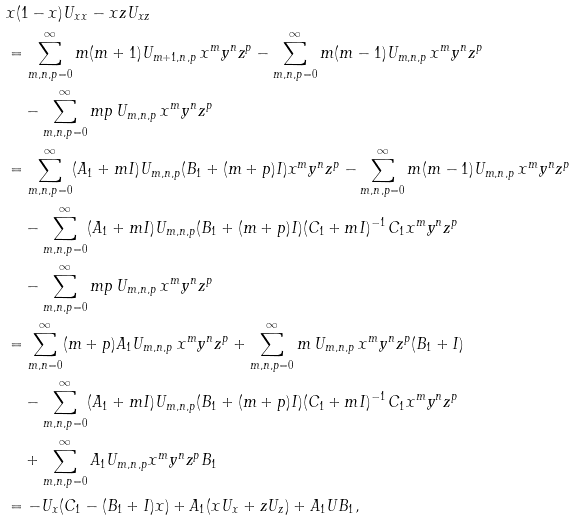<formula> <loc_0><loc_0><loc_500><loc_500>& x ( 1 - x ) U _ { x x } - x z U _ { x z } \\ & = \sum _ { m , n , p = 0 } ^ { \infty } m ( m + 1 ) U _ { m + 1 , n , p } \, x ^ { m } y ^ { n } z ^ { p } - \sum _ { m , n , p = 0 } ^ { \infty } m ( m - 1 ) U _ { m , n , p } \, x ^ { m } y ^ { n } z ^ { p } \\ & \quad - \sum _ { m , n , p = 0 } ^ { \infty } m p \, U _ { m , n , p } \, x ^ { m } y ^ { n } z ^ { p } \\ & = \sum _ { m , n , p = 0 } ^ { \infty } ( A _ { 1 } + m I ) U _ { m , n , p } ( B _ { 1 } + ( m + p ) I ) x ^ { m } y ^ { n } z ^ { p } - \sum _ { m , n , p = 0 } ^ { \infty } m ( m - 1 ) U _ { m , n , p } \, x ^ { m } y ^ { n } z ^ { p } \\ & \quad - \sum _ { m , n , p = 0 } ^ { \infty } ( A _ { 1 } + m I ) U _ { m , n , p } ( B _ { 1 } + ( m + p ) I ) ( C _ { 1 } + m I ) ^ { - 1 } \, C _ { 1 } x ^ { m } y ^ { n } z ^ { p } \\ & \quad - \sum _ { m , n , p = 0 } ^ { \infty } m p \, U _ { m , n , p } \, x ^ { m } y ^ { n } z ^ { p } \\ & = \sum _ { m , n = 0 } ^ { \infty } ( m + p ) A _ { 1 } U _ { m , n , p } \, x ^ { m } y ^ { n } z ^ { p } + \sum _ { m , n , p = 0 } ^ { \infty } m \, U _ { m , n , p } \, x ^ { m } y ^ { n } z ^ { p } ( B _ { 1 } + I ) \\ & \quad - \sum _ { m , n , p = 0 } ^ { \infty } ( A _ { 1 } + m I ) U _ { m , n , p } ( B _ { 1 } + ( m + p ) I ) ( C _ { 1 } + m I ) ^ { - 1 } \, C _ { 1 } x ^ { m } y ^ { n } z ^ { p } \\ & \quad + \sum _ { m , n , p = 0 } ^ { \infty } A _ { 1 } U _ { m , n , p } x ^ { m } y ^ { n } z ^ { p } B _ { 1 } \\ & = - U _ { x } ( C _ { 1 } - ( B _ { 1 } + I ) x ) + A _ { 1 } ( x U _ { x } + z U _ { z } ) + A _ { 1 } U B _ { 1 } ,</formula> 